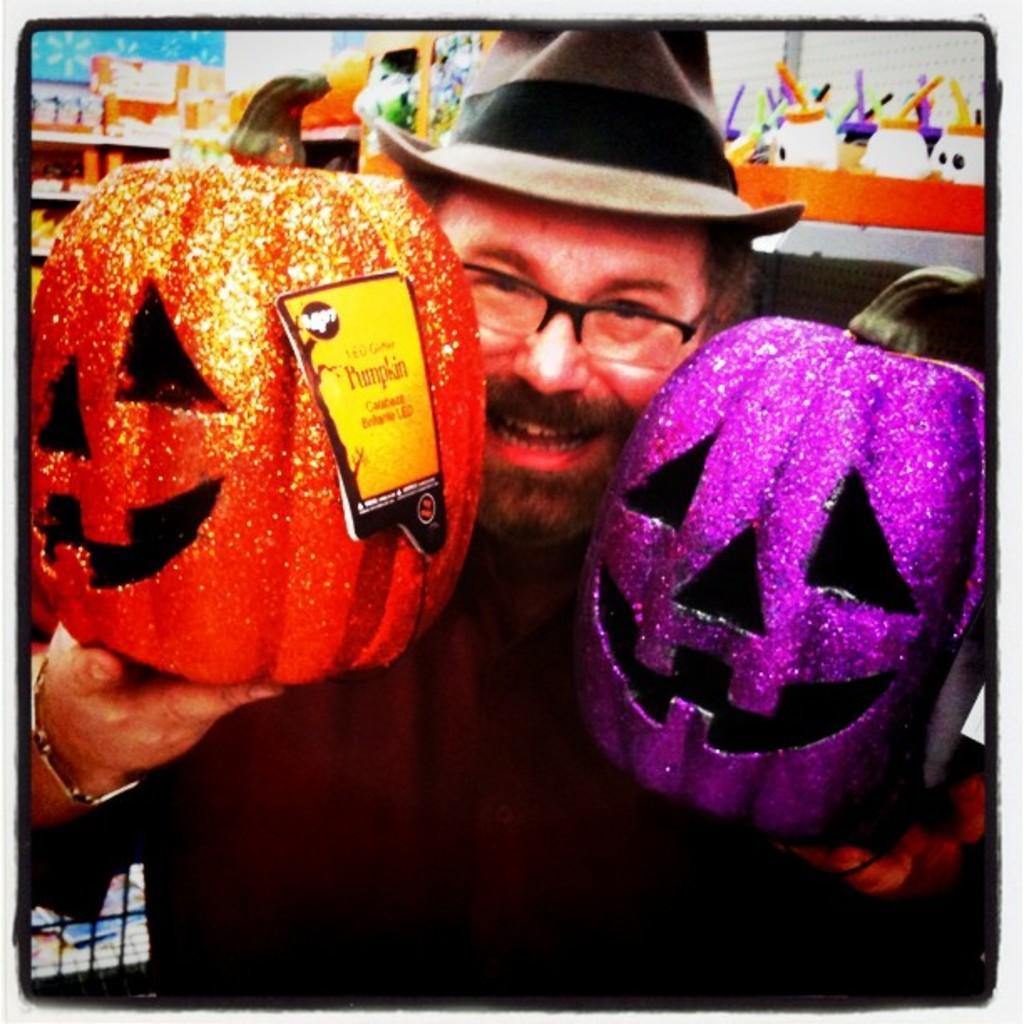Describe this image in one or two sentences. In the center of the image we can see a man standing and holding pumpkins in his hand. He is wearing a hat. In the background there is a shelf and we can see things placed in the shelf. 